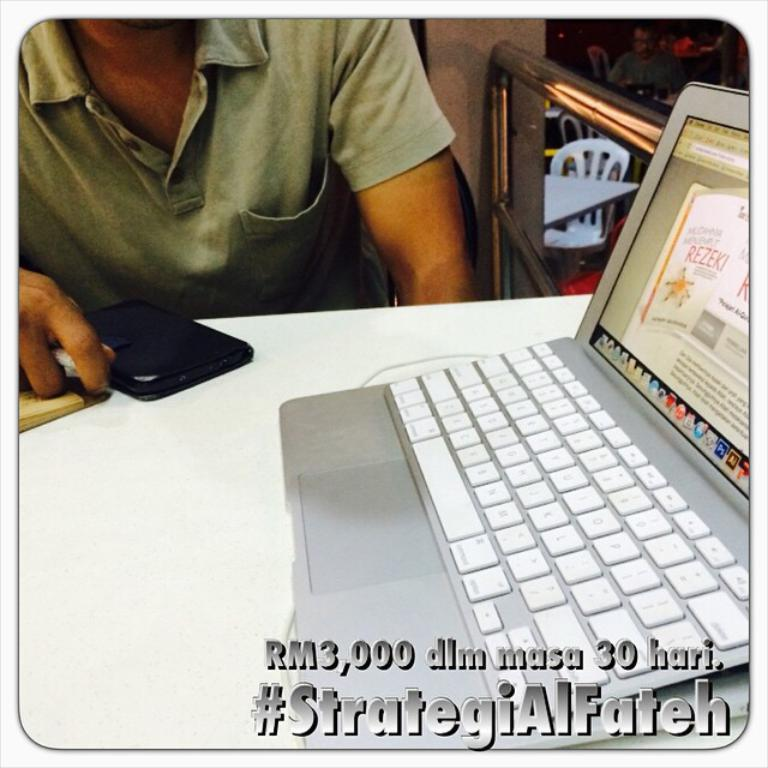<image>
Give a short and clear explanation of the subsequent image. The text at the bottom of the image is "#StrategiAlFateh". 